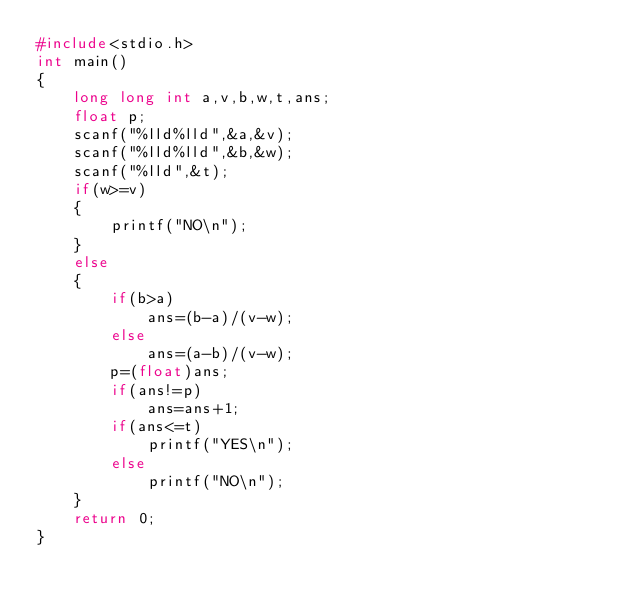Convert code to text. <code><loc_0><loc_0><loc_500><loc_500><_C_>#include<stdio.h>
int main()
{
    long long int a,v,b,w,t,ans;
    float p;
    scanf("%lld%lld",&a,&v);
    scanf("%lld%lld",&b,&w);
    scanf("%lld",&t);
    if(w>=v)
    {
        printf("NO\n");
    }
    else
    {
        if(b>a)
            ans=(b-a)/(v-w);
        else
            ans=(a-b)/(v-w);
        p=(float)ans;
        if(ans!=p)
            ans=ans+1;
        if(ans<=t)
            printf("YES\n");
        else
            printf("NO\n");
    }
    return 0;
}
</code> 